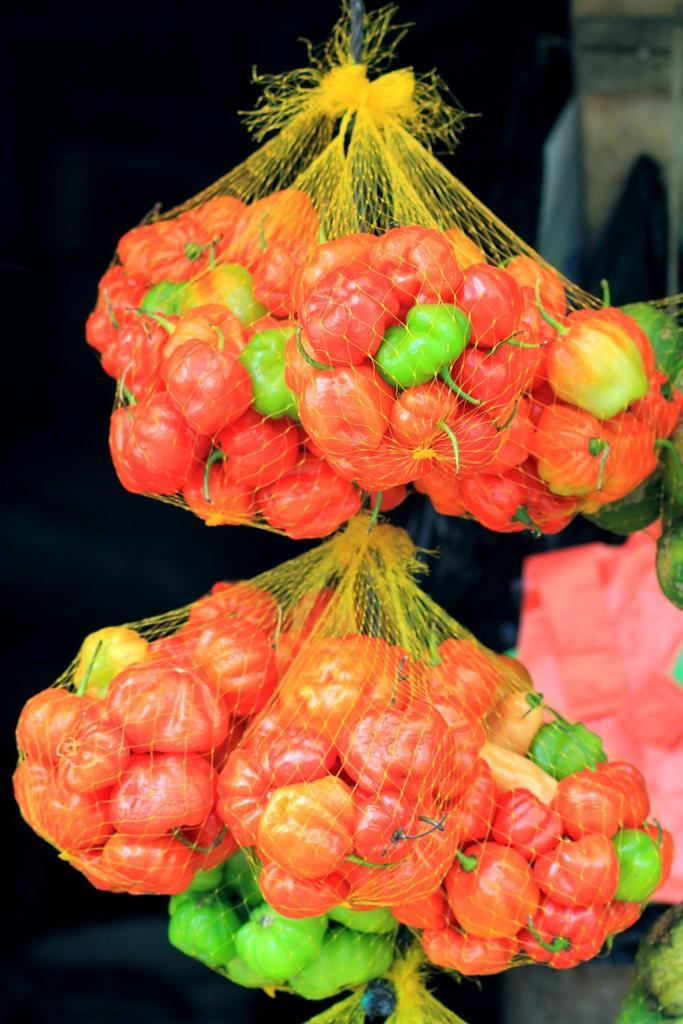In one or two sentences, can you explain what this image depicts? In this picture I can observe vegetables packed in nets. These fruits are in red and green colors. The background is dark. 